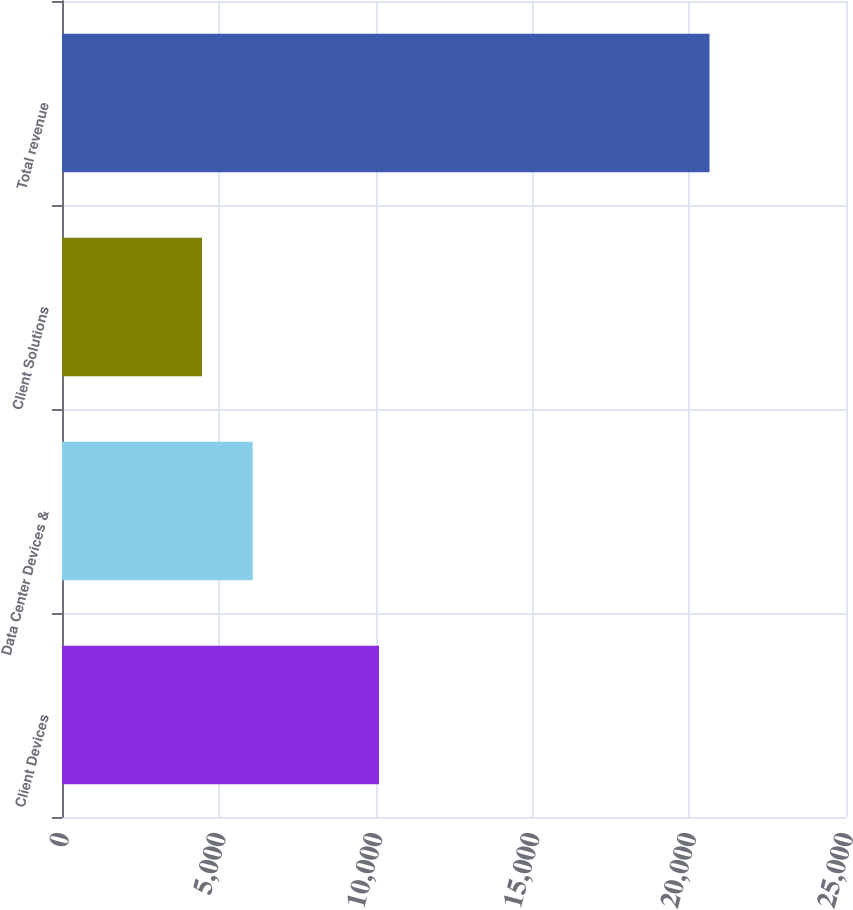Convert chart to OTSL. <chart><loc_0><loc_0><loc_500><loc_500><bar_chart><fcel>Client Devices<fcel>Data Center Devices &<fcel>Client Solutions<fcel>Total revenue<nl><fcel>10108<fcel>6082.3<fcel>4464<fcel>20647<nl></chart> 